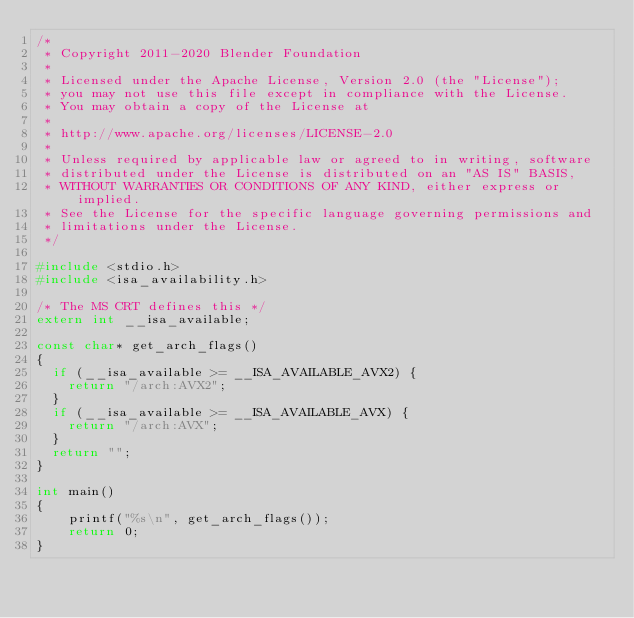Convert code to text. <code><loc_0><loc_0><loc_500><loc_500><_C_>/*
 * Copyright 2011-2020 Blender Foundation
 *
 * Licensed under the Apache License, Version 2.0 (the "License");
 * you may not use this file except in compliance with the License.
 * You may obtain a copy of the License at
 *
 * http://www.apache.org/licenses/LICENSE-2.0
 *
 * Unless required by applicable law or agreed to in writing, software
 * distributed under the License is distributed on an "AS IS" BASIS,
 * WITHOUT WARRANTIES OR CONDITIONS OF ANY KIND, either express or implied.
 * See the License for the specific language governing permissions and
 * limitations under the License.
 */

#include <stdio.h>
#include <isa_availability.h>

/* The MS CRT defines this */
extern int __isa_available;

const char* get_arch_flags()
{
	if (__isa_available >= __ISA_AVAILABLE_AVX2) {
    return "/arch:AVX2";
  }
	if (__isa_available >= __ISA_AVAILABLE_AVX) {
    return "/arch:AVX";
  }
	return "";
}

int main()
{
    printf("%s\n", get_arch_flags());
    return 0;
}
</code> 